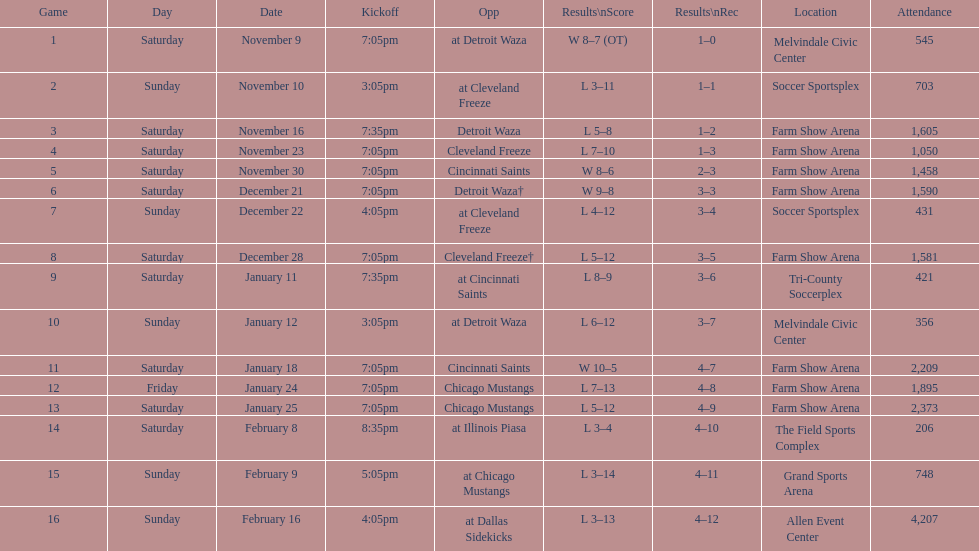What was the location before tri-county soccerplex? Farm Show Arena. Parse the full table. {'header': ['Game', 'Day', 'Date', 'Kickoff', 'Opp', 'Results\\nScore', 'Results\\nRec', 'Location', 'Attendance'], 'rows': [['1', 'Saturday', 'November 9', '7:05pm', 'at Detroit Waza', 'W 8–7 (OT)', '1–0', 'Melvindale Civic Center', '545'], ['2', 'Sunday', 'November 10', '3:05pm', 'at Cleveland Freeze', 'L 3–11', '1–1', 'Soccer Sportsplex', '703'], ['3', 'Saturday', 'November 16', '7:35pm', 'Detroit Waza', 'L 5–8', '1–2', 'Farm Show Arena', '1,605'], ['4', 'Saturday', 'November 23', '7:05pm', 'Cleveland Freeze', 'L 7–10', '1–3', 'Farm Show Arena', '1,050'], ['5', 'Saturday', 'November 30', '7:05pm', 'Cincinnati Saints', 'W 8–6', '2–3', 'Farm Show Arena', '1,458'], ['6', 'Saturday', 'December 21', '7:05pm', 'Detroit Waza†', 'W 9–8', '3–3', 'Farm Show Arena', '1,590'], ['7', 'Sunday', 'December 22', '4:05pm', 'at Cleveland Freeze', 'L 4–12', '3–4', 'Soccer Sportsplex', '431'], ['8', 'Saturday', 'December 28', '7:05pm', 'Cleveland Freeze†', 'L 5–12', '3–5', 'Farm Show Arena', '1,581'], ['9', 'Saturday', 'January 11', '7:35pm', 'at Cincinnati Saints', 'L 8–9', '3–6', 'Tri-County Soccerplex', '421'], ['10', 'Sunday', 'January 12', '3:05pm', 'at Detroit Waza', 'L 6–12', '3–7', 'Melvindale Civic Center', '356'], ['11', 'Saturday', 'January 18', '7:05pm', 'Cincinnati Saints', 'W 10–5', '4–7', 'Farm Show Arena', '2,209'], ['12', 'Friday', 'January 24', '7:05pm', 'Chicago Mustangs', 'L 7–13', '4–8', 'Farm Show Arena', '1,895'], ['13', 'Saturday', 'January 25', '7:05pm', 'Chicago Mustangs', 'L 5–12', '4–9', 'Farm Show Arena', '2,373'], ['14', 'Saturday', 'February 8', '8:35pm', 'at Illinois Piasa', 'L 3–4', '4–10', 'The Field Sports Complex', '206'], ['15', 'Sunday', 'February 9', '5:05pm', 'at Chicago Mustangs', 'L 3–14', '4–11', 'Grand Sports Arena', '748'], ['16', 'Sunday', 'February 16', '4:05pm', 'at Dallas Sidekicks', 'L 3–13', '4–12', 'Allen Event Center', '4,207']]} 